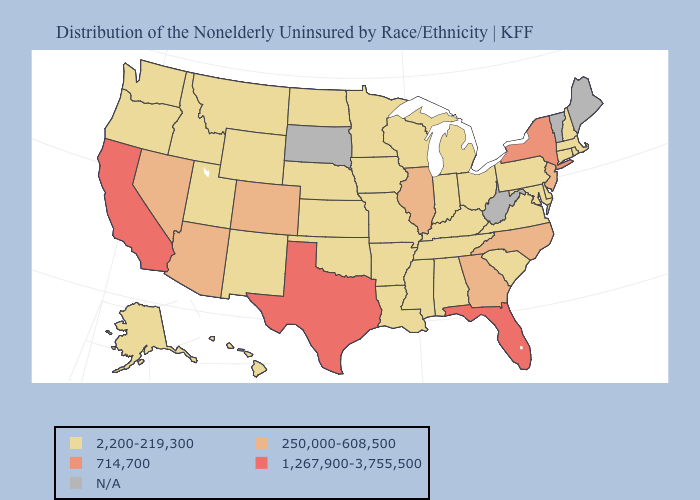What is the highest value in states that border Texas?
Give a very brief answer. 2,200-219,300. What is the value of Colorado?
Short answer required. 250,000-608,500. What is the value of Wyoming?
Short answer required. 2,200-219,300. Which states hav the highest value in the South?
Keep it brief. Florida, Texas. Does Massachusetts have the lowest value in the Northeast?
Short answer required. Yes. Name the states that have a value in the range 714,700?
Keep it brief. New York. What is the value of North Dakota?
Answer briefly. 2,200-219,300. What is the value of Delaware?
Short answer required. 2,200-219,300. What is the highest value in the USA?
Short answer required. 1,267,900-3,755,500. What is the lowest value in the USA?
Answer briefly. 2,200-219,300. Name the states that have a value in the range 2,200-219,300?
Answer briefly. Alabama, Alaska, Arkansas, Connecticut, Delaware, Hawaii, Idaho, Indiana, Iowa, Kansas, Kentucky, Louisiana, Maryland, Massachusetts, Michigan, Minnesota, Mississippi, Missouri, Montana, Nebraska, New Hampshire, New Mexico, North Dakota, Ohio, Oklahoma, Oregon, Pennsylvania, Rhode Island, South Carolina, Tennessee, Utah, Virginia, Washington, Wisconsin, Wyoming. What is the lowest value in the USA?
Short answer required. 2,200-219,300. Name the states that have a value in the range 714,700?
Give a very brief answer. New York. Does the first symbol in the legend represent the smallest category?
Write a very short answer. Yes. 